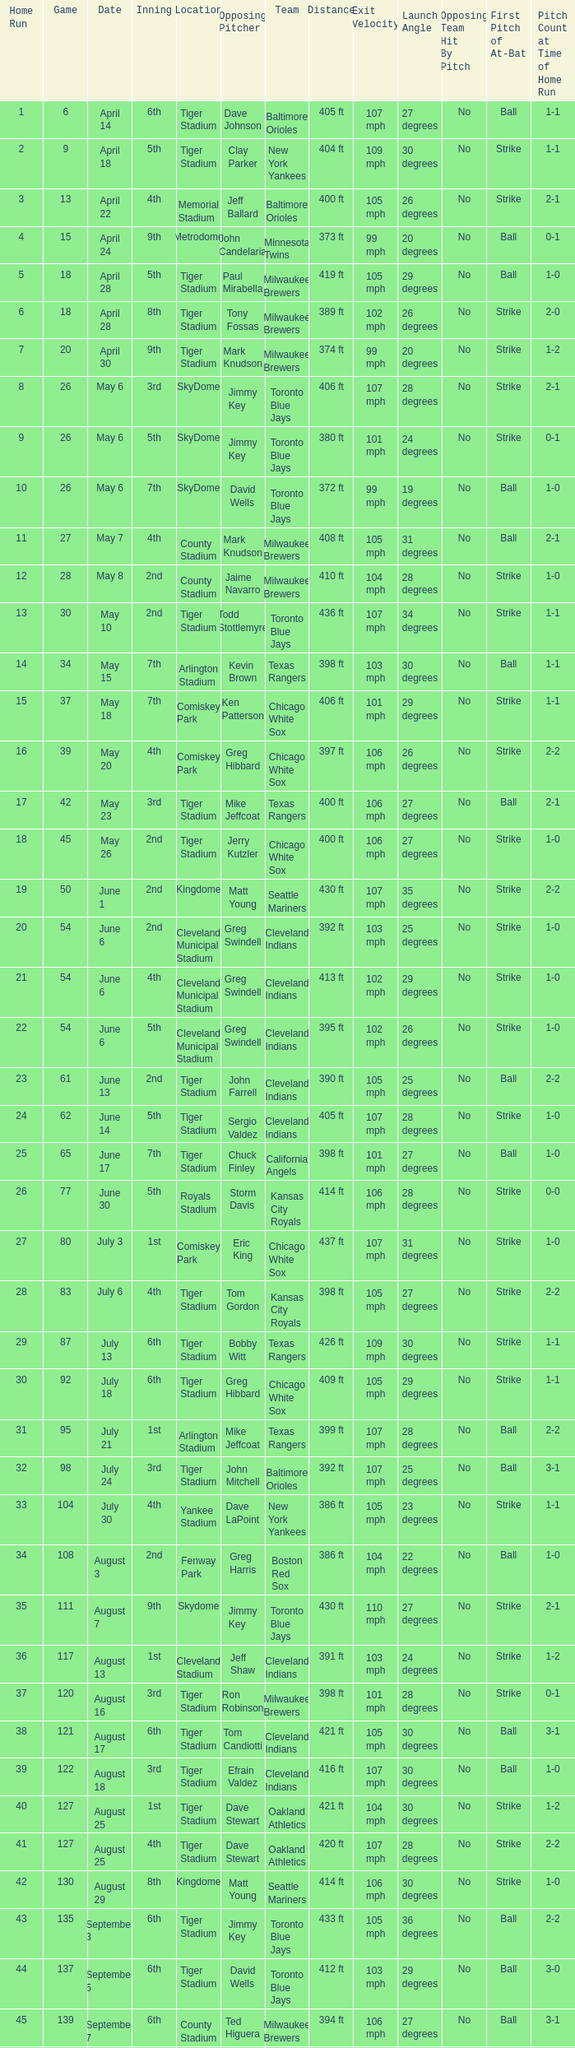What date was the game at Comiskey Park and had a 4th Inning? May 20. 